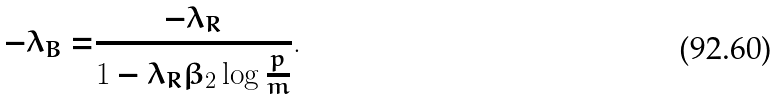<formula> <loc_0><loc_0><loc_500><loc_500>- \lambda _ { B } = & \frac { - \lambda _ { R } } { 1 - \lambda _ { R } \beta _ { 2 } \log \frac { p } { m } } .</formula> 